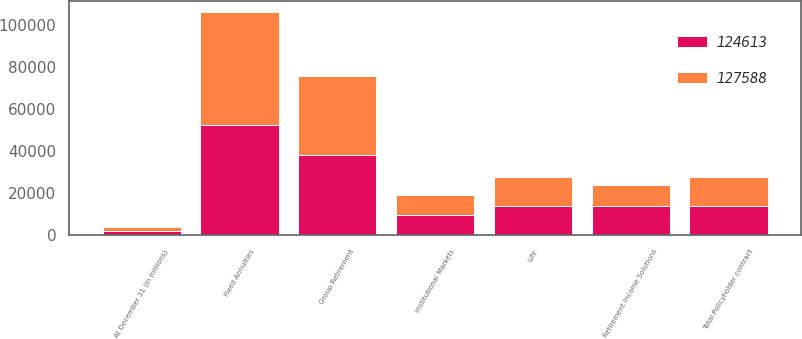<chart> <loc_0><loc_0><loc_500><loc_500><stacked_bar_chart><ecel><fcel>At December 31 (in millions)<fcel>Fixed Annuities<fcel>Group Retirement<fcel>Life<fcel>Retirement Income Solutions<fcel>Institutional Markets<fcel>Total Policyholder contract<nl><fcel>124613<fcel>2015<fcel>52397<fcel>37865<fcel>14028<fcel>13927<fcel>9371<fcel>13822<nl><fcel>127588<fcel>2014<fcel>53370<fcel>37693<fcel>13717<fcel>10040<fcel>9793<fcel>13822<nl></chart> 